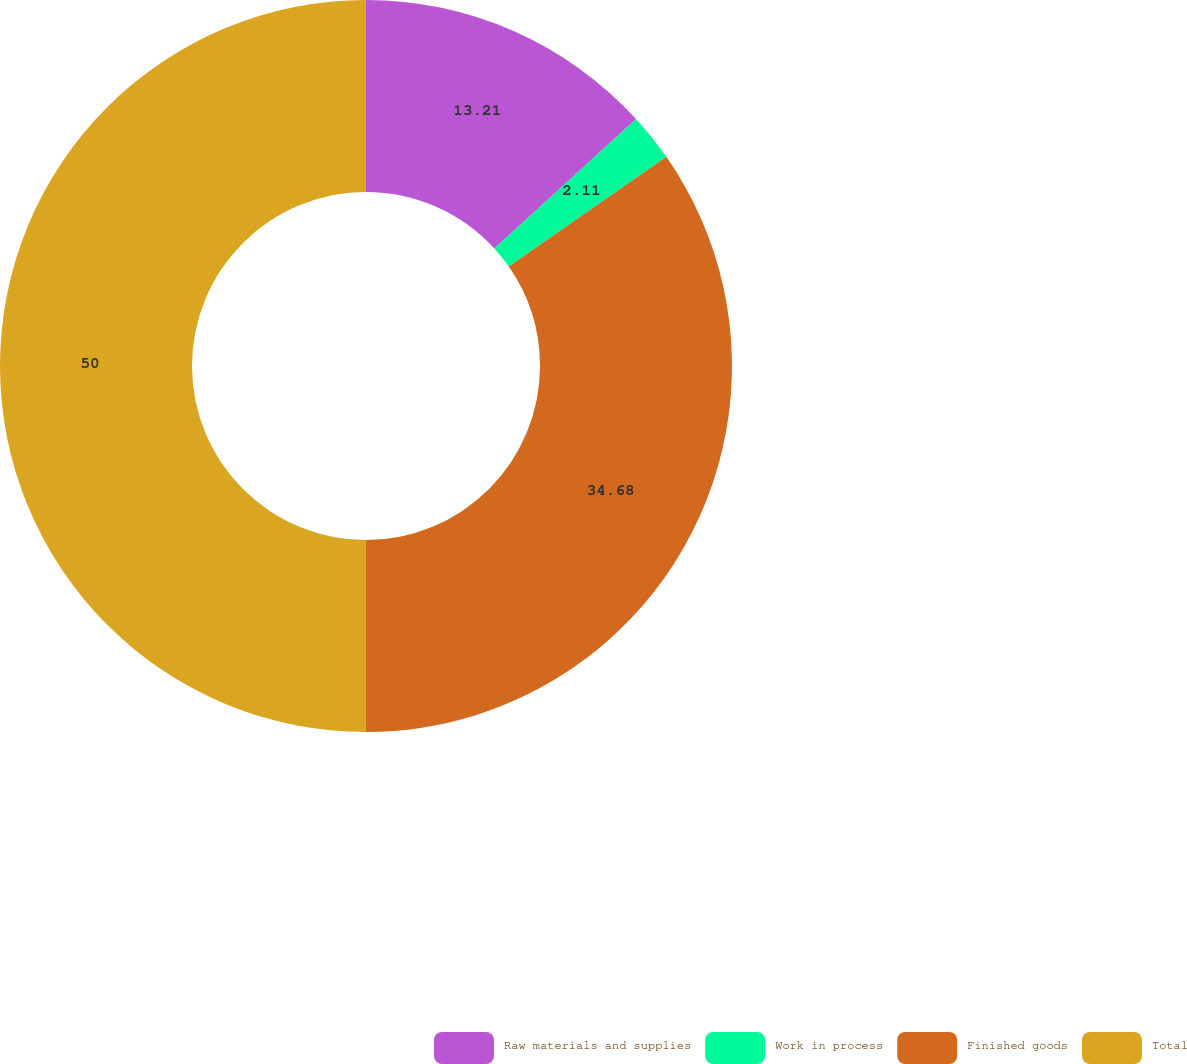<chart> <loc_0><loc_0><loc_500><loc_500><pie_chart><fcel>Raw materials and supplies<fcel>Work in process<fcel>Finished goods<fcel>Total<nl><fcel>13.21%<fcel>2.11%<fcel>34.68%<fcel>50.0%<nl></chart> 